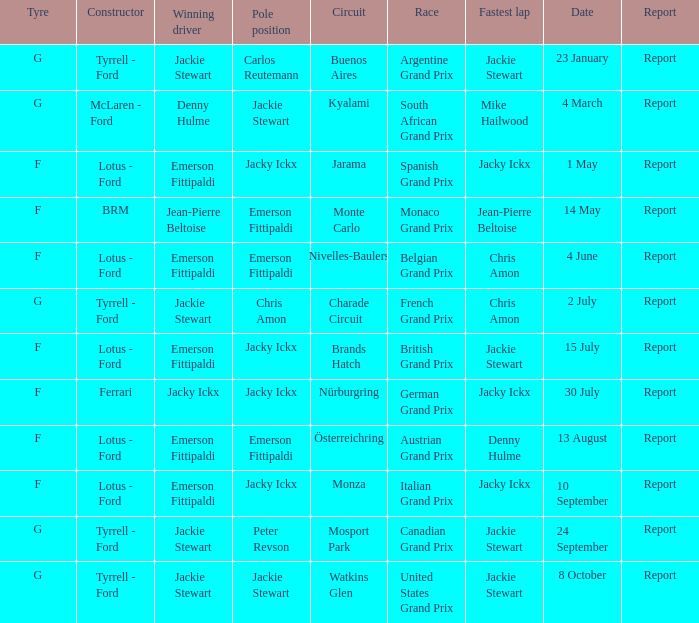What day did Emerson Fittipaldi win the Spanish Grand Prix? 1 May. 